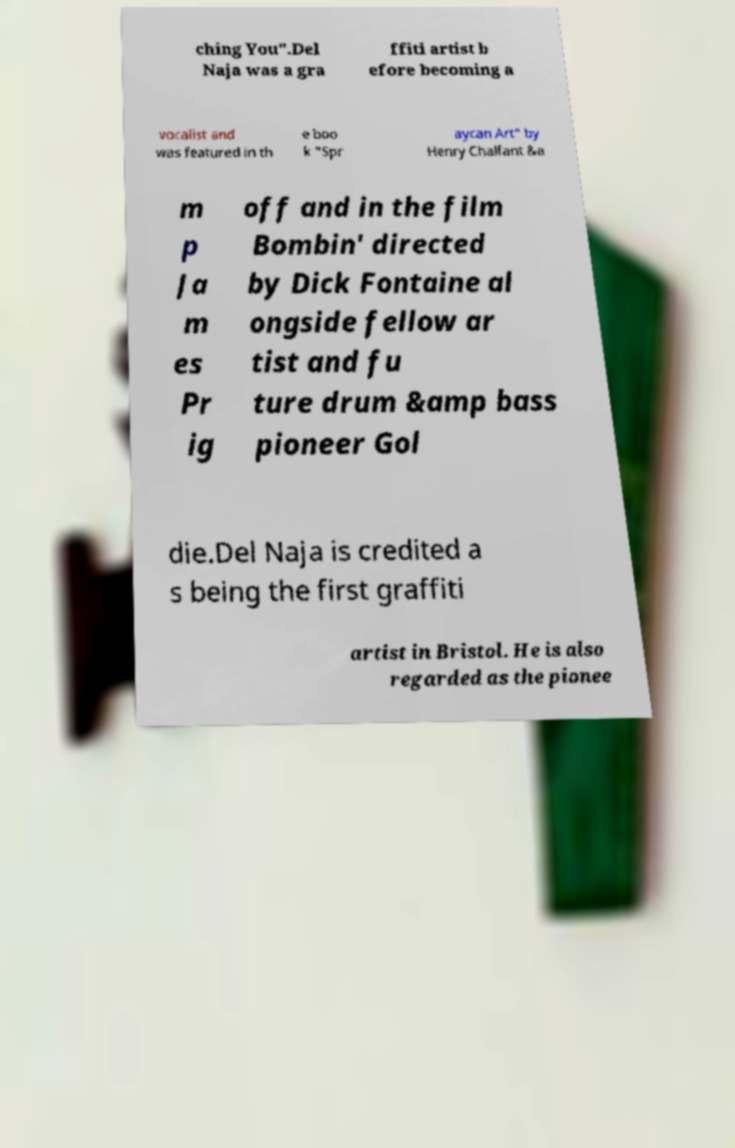There's text embedded in this image that I need extracted. Can you transcribe it verbatim? ching You".Del Naja was a gra ffiti artist b efore becoming a vocalist and was featured in th e boo k "Spr aycan Art" by Henry Chalfant &a m p Ja m es Pr ig off and in the film Bombin' directed by Dick Fontaine al ongside fellow ar tist and fu ture drum &amp bass pioneer Gol die.Del Naja is credited a s being the first graffiti artist in Bristol. He is also regarded as the pionee 